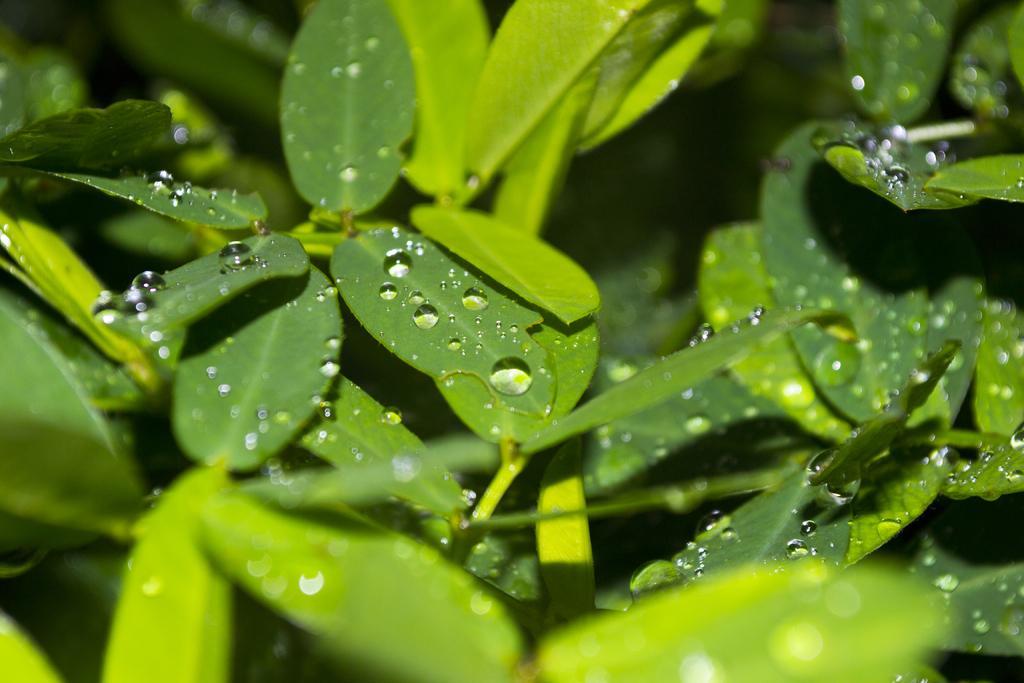Can you describe this image briefly? This picture contains trees or plants. We see the droplets of water on the leaves of the plants. In the background, it is blurred. 